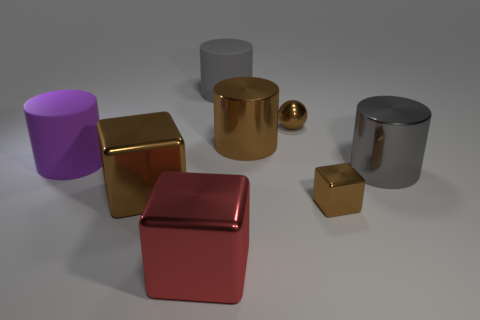Subtract all big purple cylinders. How many cylinders are left? 3 Add 1 gray metallic things. How many objects exist? 9 Subtract all red cylinders. How many brown blocks are left? 2 Subtract all brown cylinders. How many cylinders are left? 3 Subtract all cubes. How many objects are left? 5 Subtract 1 cubes. How many cubes are left? 2 Subtract 0 cyan cylinders. How many objects are left? 8 Subtract all green blocks. Subtract all green cylinders. How many blocks are left? 3 Subtract all small yellow balls. Subtract all rubber objects. How many objects are left? 6 Add 1 large purple cylinders. How many large purple cylinders are left? 2 